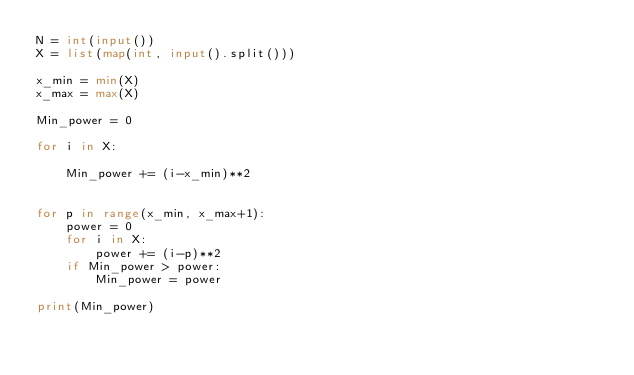Convert code to text. <code><loc_0><loc_0><loc_500><loc_500><_Python_>N = int(input())
X = list(map(int, input().split()))

x_min = min(X)
x_max = max(X)

Min_power = 0

for i in X:

    Min_power += (i-x_min)**2


for p in range(x_min, x_max+1):
    power = 0
    for i in X:
        power += (i-p)**2
    if Min_power > power:
        Min_power = power

print(Min_power)
</code> 